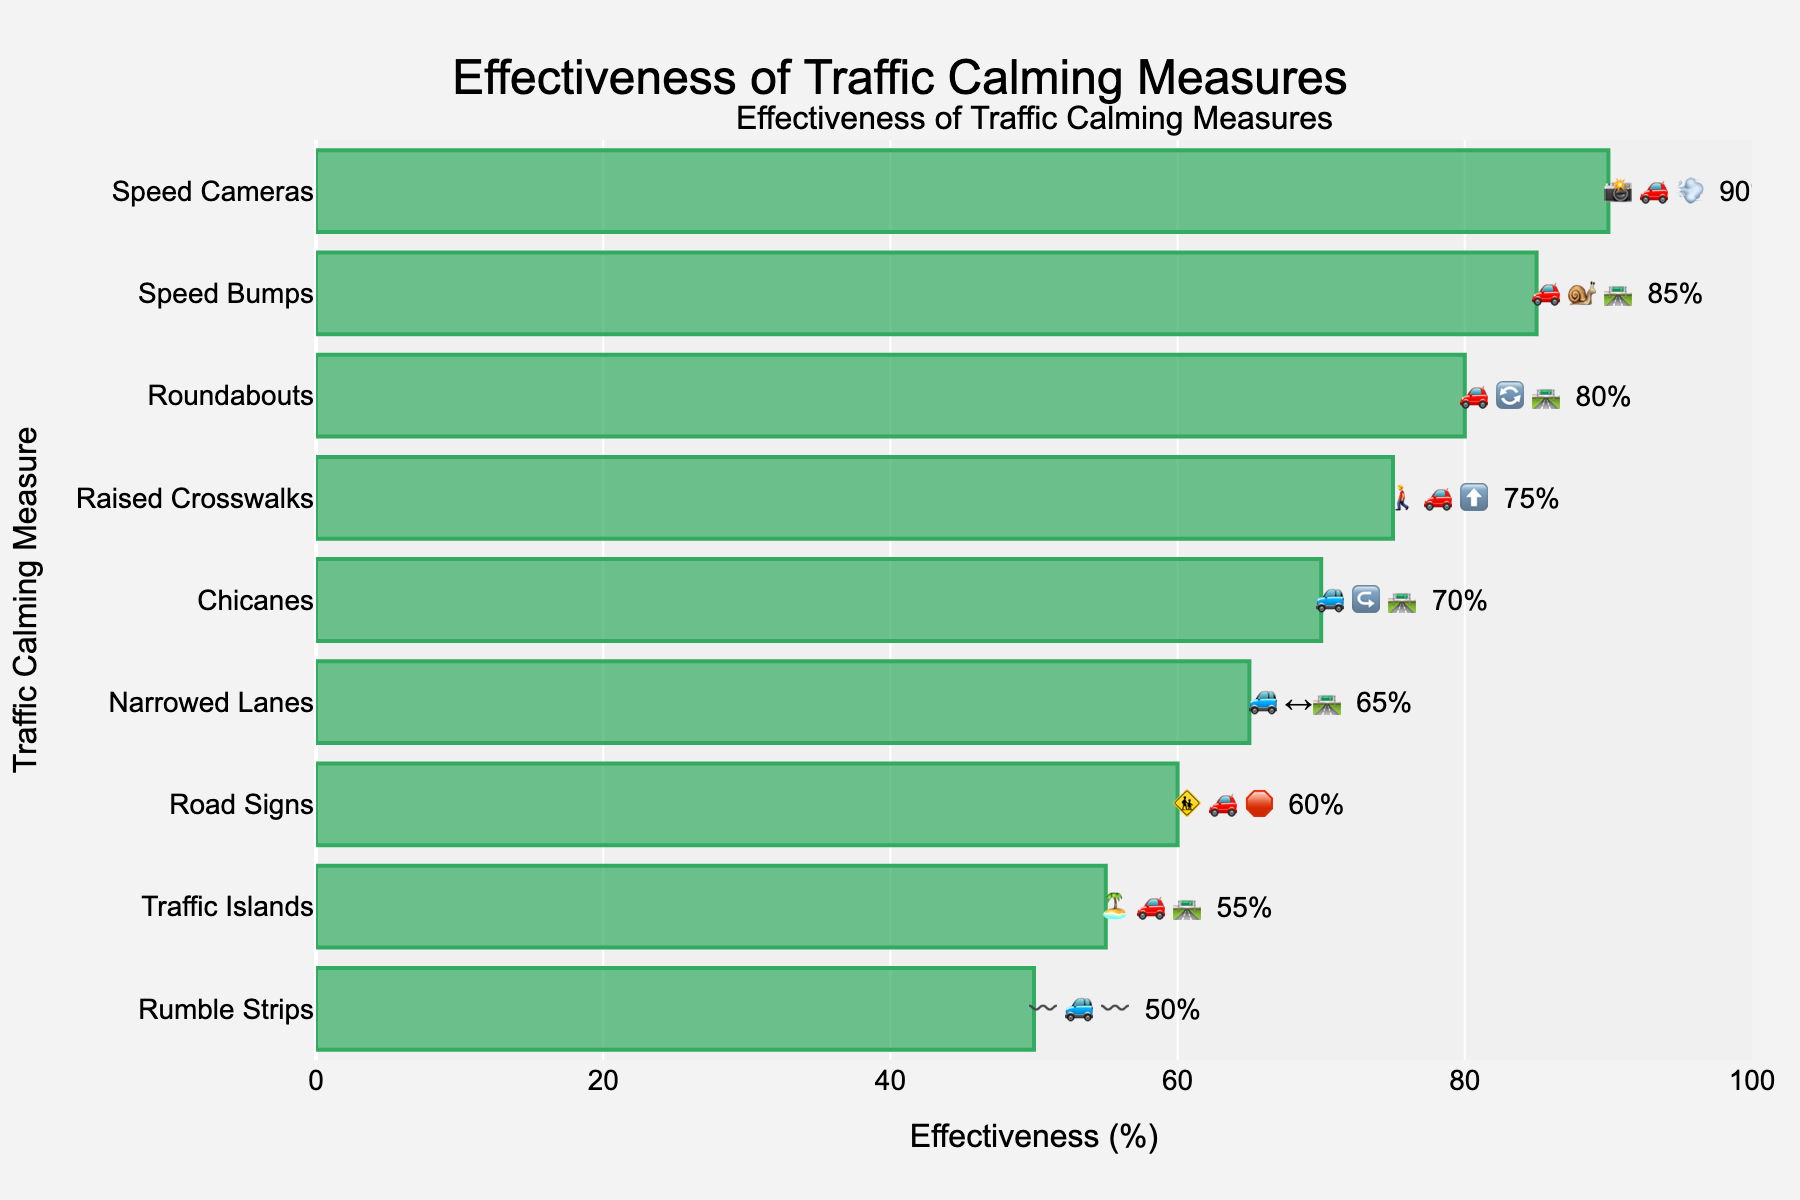what is the title of the figure? The title is usually found at the top center of the figure. It is meant to summarize what the figure is about.
Answer: Effectiveness of Traffic Calming Measures Which traffic calming measure has the highest effectiveness? By looking at the effectiveness values and ranking them in descending order, the measure with the highest value will have the highest effectiveness.
Answer: Speed Cameras What are the effectiveness percentages of Raised Crosswalks and Roundabouts? Locate the bars for Raised Crosswalks and Roundabouts and read the effectiveness percentages next to them.
Answer: 75% and 80% How much more effective are Speed Cameras compared to Traffic Islands? Find the effectiveness percentages for both Speed Cameras and Traffic Islands, then subtract the lesser percentage from the greater one.
Answer: 90% - 55% = 35% Which measure has a lower effectiveness: Chicanes or Narrowed Lanes? Locate the bars for Chicanes and Narrowed Lanes and compare their effectiveness percentages.
Answer: Narrowed Lanes What emojis represent Speed Bumps and Rumble Strips? Identify the bars for Speed Bumps and Rumble Strips and read the emojis next to them.
Answer: 🚗🐌🛣️ and 〰️🚙〰️ Arrange the traffic calming measures in ascending order of effectiveness. By looking at the effectiveness percentages from lowest to highest, list the measures accordingly.
Answer: Rumble Strips, Traffic Islands, Road Signs, Narrowed Lanes, Chicanes, Raised Crosswalks, Roundabouts, Speed Bumps, Speed Cameras What is the average effectiveness of Speed Bumps, Chicanes, and Raised Crosswalks? Add the effectiveness percentages of Speed Bumps, Chicanes, and Raised Crosswalks, then divide by 3.
Answer: (85% + 70% + 75%) / 3 = 76.67% How does the effectiveness of Roundabouts compare to Road Signs? Compare the effectiveness percentages between the Roundabouts and Road Signs.
Answer: 80% is greater than 60% Which measure has the most complex emoji representation and what is it? Locate the measure whose emoji representation is more intricate or longer, based on the visual complexity and number of elements.
Answer: Rumble Strips: 〰️🚙〰️ 